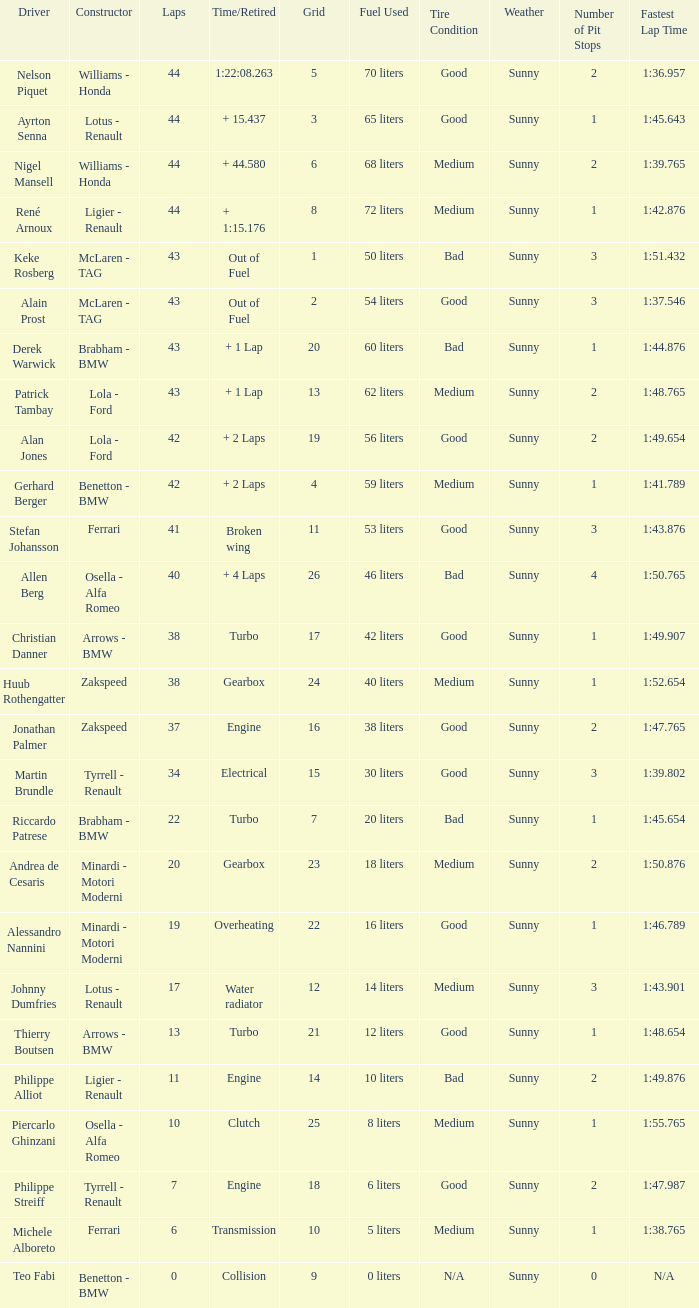Tell me the time/retired for Laps of 42 and Grids of 4 + 2 Laps. 